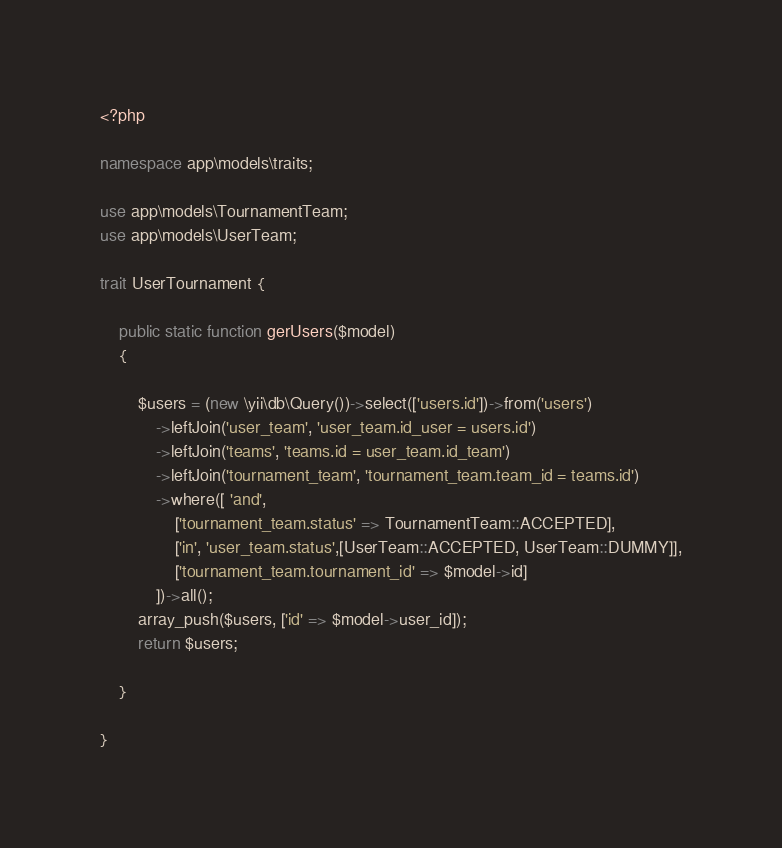Convert code to text. <code><loc_0><loc_0><loc_500><loc_500><_PHP_><?php

namespace app\models\traits;

use app\models\TournamentTeam;
use app\models\UserTeam;

trait UserTournament {
    
    public static function gerUsers($model) 
    {

        $users = (new \yii\db\Query())->select(['users.id'])->from('users')
            ->leftJoin('user_team', 'user_team.id_user = users.id')
            ->leftJoin('teams', 'teams.id = user_team.id_team')
            ->leftJoin('tournament_team', 'tournament_team.team_id = teams.id')
            ->where([ 'and',
                ['tournament_team.status' => TournamentTeam::ACCEPTED],
                ['in', 'user_team.status',[UserTeam::ACCEPTED, UserTeam::DUMMY]],
                ['tournament_team.tournament_id' => $model->id]
            ])->all();
        array_push($users, ['id' => $model->user_id]);
        return $users;

    }

}</code> 